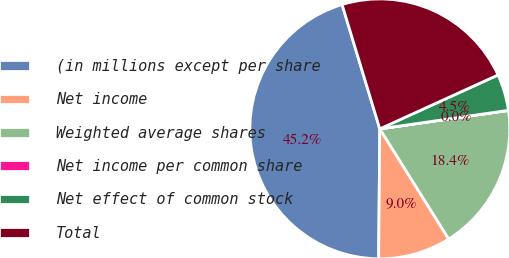Convert chart. <chart><loc_0><loc_0><loc_500><loc_500><pie_chart><fcel>(in millions except per share<fcel>Net income<fcel>Weighted average shares<fcel>Net income per common share<fcel>Net effect of common stock<fcel>Total<nl><fcel>45.17%<fcel>9.04%<fcel>18.37%<fcel>0.01%<fcel>4.53%<fcel>22.88%<nl></chart> 